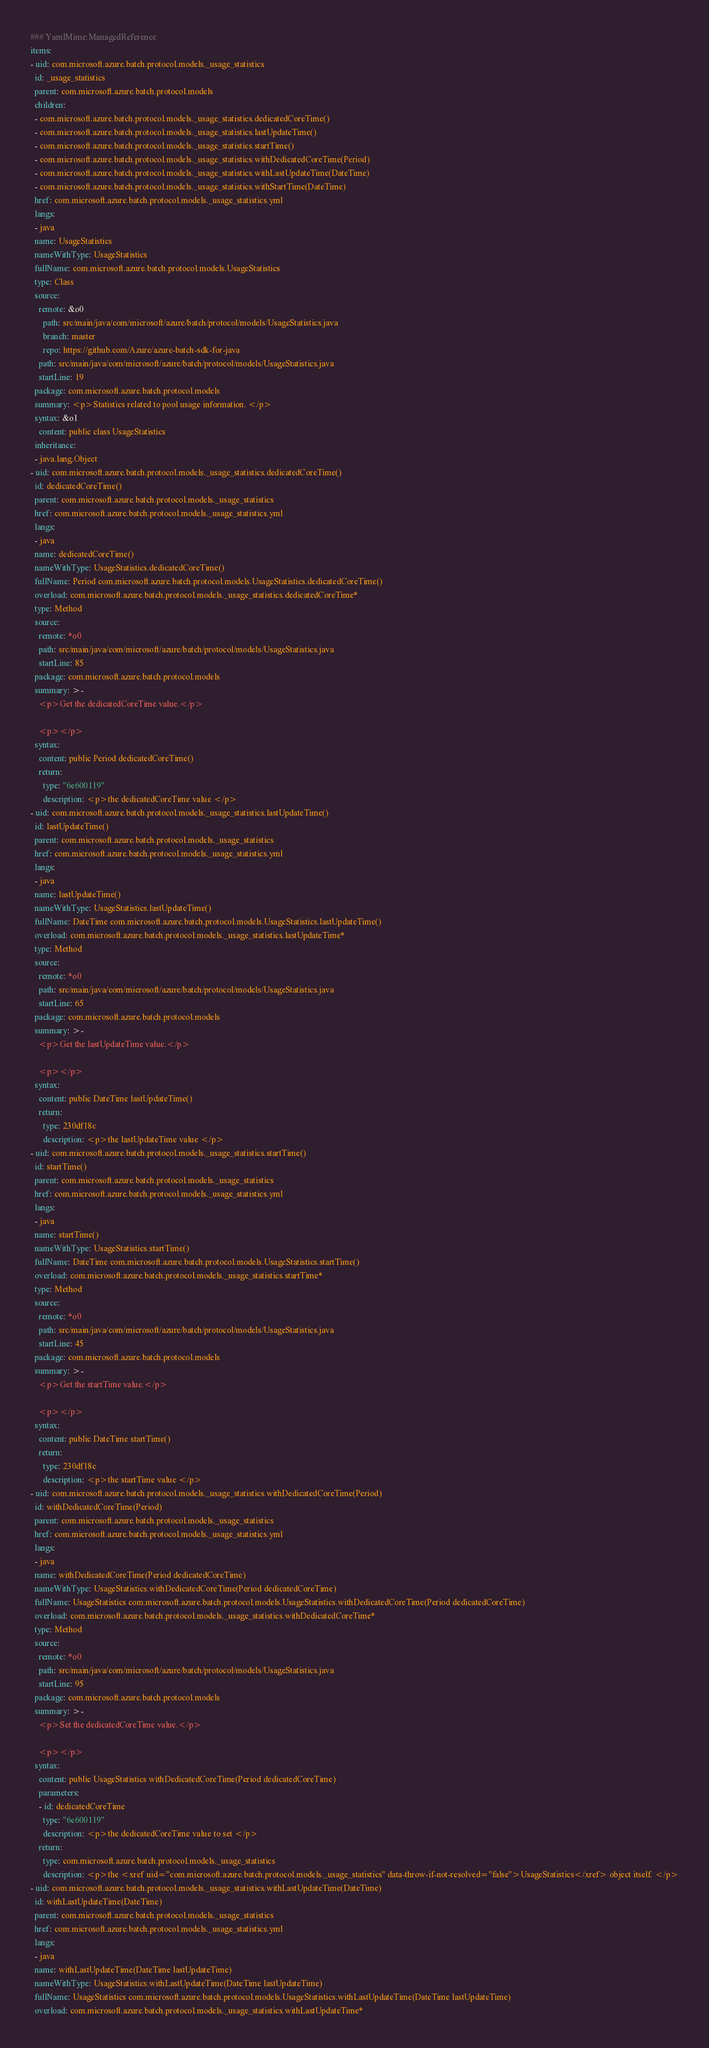<code> <loc_0><loc_0><loc_500><loc_500><_YAML_>### YamlMime:ManagedReference
items:
- uid: com.microsoft.azure.batch.protocol.models._usage_statistics
  id: _usage_statistics
  parent: com.microsoft.azure.batch.protocol.models
  children:
  - com.microsoft.azure.batch.protocol.models._usage_statistics.dedicatedCoreTime()
  - com.microsoft.azure.batch.protocol.models._usage_statistics.lastUpdateTime()
  - com.microsoft.azure.batch.protocol.models._usage_statistics.startTime()
  - com.microsoft.azure.batch.protocol.models._usage_statistics.withDedicatedCoreTime(Period)
  - com.microsoft.azure.batch.protocol.models._usage_statistics.withLastUpdateTime(DateTime)
  - com.microsoft.azure.batch.protocol.models._usage_statistics.withStartTime(DateTime)
  href: com.microsoft.azure.batch.protocol.models._usage_statistics.yml
  langs:
  - java
  name: UsageStatistics
  nameWithType: UsageStatistics
  fullName: com.microsoft.azure.batch.protocol.models.UsageStatistics
  type: Class
  source:
    remote: &o0
      path: src/main/java/com/microsoft/azure/batch/protocol/models/UsageStatistics.java
      branch: master
      repo: https://github.com/Azure/azure-batch-sdk-for-java
    path: src/main/java/com/microsoft/azure/batch/protocol/models/UsageStatistics.java
    startLine: 19
  package: com.microsoft.azure.batch.protocol.models
  summary: <p>Statistics related to pool usage information. </p>
  syntax: &o1
    content: public class UsageStatistics
  inheritance:
  - java.lang.Object
- uid: com.microsoft.azure.batch.protocol.models._usage_statistics.dedicatedCoreTime()
  id: dedicatedCoreTime()
  parent: com.microsoft.azure.batch.protocol.models._usage_statistics
  href: com.microsoft.azure.batch.protocol.models._usage_statistics.yml
  langs:
  - java
  name: dedicatedCoreTime()
  nameWithType: UsageStatistics.dedicatedCoreTime()
  fullName: Period com.microsoft.azure.batch.protocol.models.UsageStatistics.dedicatedCoreTime()
  overload: com.microsoft.azure.batch.protocol.models._usage_statistics.dedicatedCoreTime*
  type: Method
  source:
    remote: *o0
    path: src/main/java/com/microsoft/azure/batch/protocol/models/UsageStatistics.java
    startLine: 85
  package: com.microsoft.azure.batch.protocol.models
  summary: >-
    <p>Get the dedicatedCoreTime value.</p>

    <p></p>
  syntax:
    content: public Period dedicatedCoreTime()
    return:
      type: "6e600119"
      description: <p>the dedicatedCoreTime value </p>
- uid: com.microsoft.azure.batch.protocol.models._usage_statistics.lastUpdateTime()
  id: lastUpdateTime()
  parent: com.microsoft.azure.batch.protocol.models._usage_statistics
  href: com.microsoft.azure.batch.protocol.models._usage_statistics.yml
  langs:
  - java
  name: lastUpdateTime()
  nameWithType: UsageStatistics.lastUpdateTime()
  fullName: DateTime com.microsoft.azure.batch.protocol.models.UsageStatistics.lastUpdateTime()
  overload: com.microsoft.azure.batch.protocol.models._usage_statistics.lastUpdateTime*
  type: Method
  source:
    remote: *o0
    path: src/main/java/com/microsoft/azure/batch/protocol/models/UsageStatistics.java
    startLine: 65
  package: com.microsoft.azure.batch.protocol.models
  summary: >-
    <p>Get the lastUpdateTime value.</p>

    <p></p>
  syntax:
    content: public DateTime lastUpdateTime()
    return:
      type: 230df18c
      description: <p>the lastUpdateTime value </p>
- uid: com.microsoft.azure.batch.protocol.models._usage_statistics.startTime()
  id: startTime()
  parent: com.microsoft.azure.batch.protocol.models._usage_statistics
  href: com.microsoft.azure.batch.protocol.models._usage_statistics.yml
  langs:
  - java
  name: startTime()
  nameWithType: UsageStatistics.startTime()
  fullName: DateTime com.microsoft.azure.batch.protocol.models.UsageStatistics.startTime()
  overload: com.microsoft.azure.batch.protocol.models._usage_statistics.startTime*
  type: Method
  source:
    remote: *o0
    path: src/main/java/com/microsoft/azure/batch/protocol/models/UsageStatistics.java
    startLine: 45
  package: com.microsoft.azure.batch.protocol.models
  summary: >-
    <p>Get the startTime value.</p>

    <p></p>
  syntax:
    content: public DateTime startTime()
    return:
      type: 230df18c
      description: <p>the startTime value </p>
- uid: com.microsoft.azure.batch.protocol.models._usage_statistics.withDedicatedCoreTime(Period)
  id: withDedicatedCoreTime(Period)
  parent: com.microsoft.azure.batch.protocol.models._usage_statistics
  href: com.microsoft.azure.batch.protocol.models._usage_statistics.yml
  langs:
  - java
  name: withDedicatedCoreTime(Period dedicatedCoreTime)
  nameWithType: UsageStatistics.withDedicatedCoreTime(Period dedicatedCoreTime)
  fullName: UsageStatistics com.microsoft.azure.batch.protocol.models.UsageStatistics.withDedicatedCoreTime(Period dedicatedCoreTime)
  overload: com.microsoft.azure.batch.protocol.models._usage_statistics.withDedicatedCoreTime*
  type: Method
  source:
    remote: *o0
    path: src/main/java/com/microsoft/azure/batch/protocol/models/UsageStatistics.java
    startLine: 95
  package: com.microsoft.azure.batch.protocol.models
  summary: >-
    <p>Set the dedicatedCoreTime value.</p>

    <p></p>
  syntax:
    content: public UsageStatistics withDedicatedCoreTime(Period dedicatedCoreTime)
    parameters:
    - id: dedicatedCoreTime
      type: "6e600119"
      description: <p>the dedicatedCoreTime value to set </p>
    return:
      type: com.microsoft.azure.batch.protocol.models._usage_statistics
      description: <p>the <xref uid="com.microsoft.azure.batch.protocol.models._usage_statistics" data-throw-if-not-resolved="false">UsageStatistics</xref> object itself. </p>
- uid: com.microsoft.azure.batch.protocol.models._usage_statistics.withLastUpdateTime(DateTime)
  id: withLastUpdateTime(DateTime)
  parent: com.microsoft.azure.batch.protocol.models._usage_statistics
  href: com.microsoft.azure.batch.protocol.models._usage_statistics.yml
  langs:
  - java
  name: withLastUpdateTime(DateTime lastUpdateTime)
  nameWithType: UsageStatistics.withLastUpdateTime(DateTime lastUpdateTime)
  fullName: UsageStatistics com.microsoft.azure.batch.protocol.models.UsageStatistics.withLastUpdateTime(DateTime lastUpdateTime)
  overload: com.microsoft.azure.batch.protocol.models._usage_statistics.withLastUpdateTime*</code> 